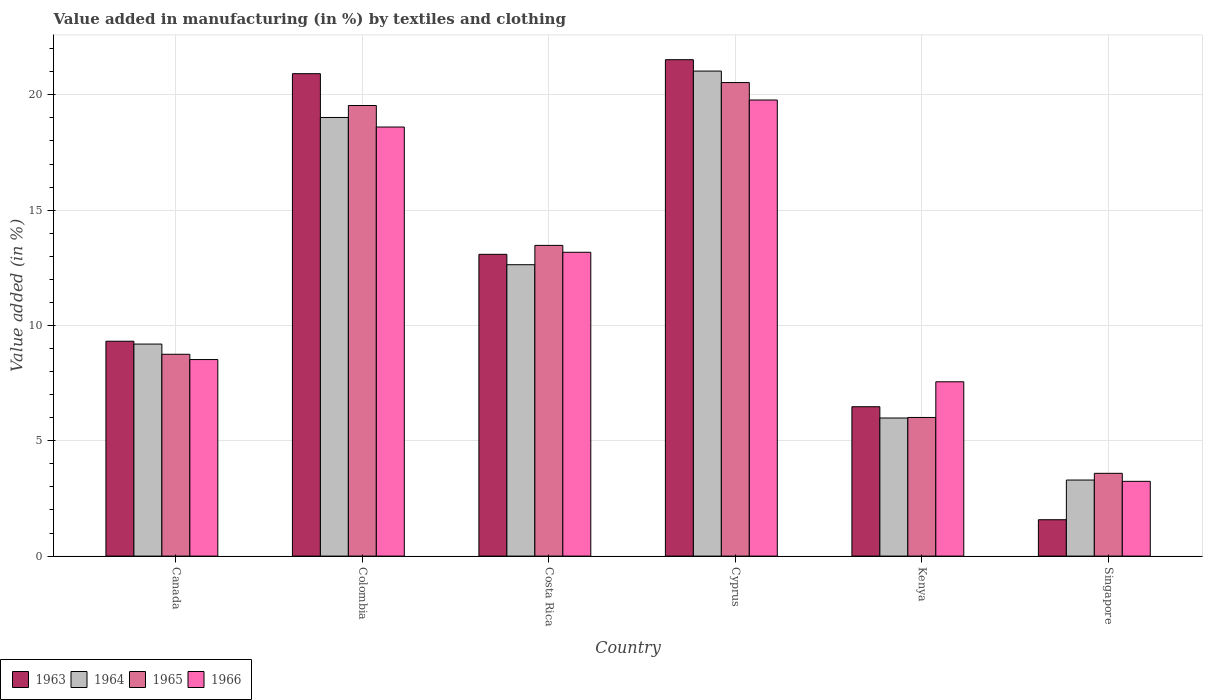Are the number of bars on each tick of the X-axis equal?
Provide a short and direct response. Yes. What is the label of the 4th group of bars from the left?
Your response must be concise. Cyprus. What is the percentage of value added in manufacturing by textiles and clothing in 1966 in Cyprus?
Offer a terse response. 19.78. Across all countries, what is the maximum percentage of value added in manufacturing by textiles and clothing in 1966?
Ensure brevity in your answer.  19.78. Across all countries, what is the minimum percentage of value added in manufacturing by textiles and clothing in 1964?
Offer a very short reply. 3.3. In which country was the percentage of value added in manufacturing by textiles and clothing in 1964 maximum?
Keep it short and to the point. Cyprus. In which country was the percentage of value added in manufacturing by textiles and clothing in 1966 minimum?
Offer a terse response. Singapore. What is the total percentage of value added in manufacturing by textiles and clothing in 1964 in the graph?
Ensure brevity in your answer.  71.16. What is the difference between the percentage of value added in manufacturing by textiles and clothing in 1966 in Colombia and that in Singapore?
Provide a short and direct response. 15.36. What is the difference between the percentage of value added in manufacturing by textiles and clothing in 1963 in Costa Rica and the percentage of value added in manufacturing by textiles and clothing in 1964 in Colombia?
Your answer should be very brief. -5.93. What is the average percentage of value added in manufacturing by textiles and clothing in 1966 per country?
Keep it short and to the point. 11.81. What is the difference between the percentage of value added in manufacturing by textiles and clothing of/in 1965 and percentage of value added in manufacturing by textiles and clothing of/in 1963 in Canada?
Your answer should be very brief. -0.57. What is the ratio of the percentage of value added in manufacturing by textiles and clothing in 1963 in Cyprus to that in Kenya?
Offer a terse response. 3.32. What is the difference between the highest and the second highest percentage of value added in manufacturing by textiles and clothing in 1965?
Ensure brevity in your answer.  -0.99. What is the difference between the highest and the lowest percentage of value added in manufacturing by textiles and clothing in 1965?
Your answer should be compact. 16.94. Is it the case that in every country, the sum of the percentage of value added in manufacturing by textiles and clothing in 1965 and percentage of value added in manufacturing by textiles and clothing in 1963 is greater than the sum of percentage of value added in manufacturing by textiles and clothing in 1964 and percentage of value added in manufacturing by textiles and clothing in 1966?
Offer a very short reply. No. What does the 4th bar from the left in Cyprus represents?
Your answer should be very brief. 1966. Is it the case that in every country, the sum of the percentage of value added in manufacturing by textiles and clothing in 1963 and percentage of value added in manufacturing by textiles and clothing in 1965 is greater than the percentage of value added in manufacturing by textiles and clothing in 1966?
Your response must be concise. Yes. How many bars are there?
Offer a terse response. 24. Are all the bars in the graph horizontal?
Make the answer very short. No. How many countries are there in the graph?
Make the answer very short. 6. What is the difference between two consecutive major ticks on the Y-axis?
Offer a terse response. 5. Does the graph contain any zero values?
Keep it short and to the point. No. How many legend labels are there?
Your answer should be compact. 4. What is the title of the graph?
Provide a succinct answer. Value added in manufacturing (in %) by textiles and clothing. What is the label or title of the X-axis?
Your response must be concise. Country. What is the label or title of the Y-axis?
Your response must be concise. Value added (in %). What is the Value added (in %) of 1963 in Canada?
Your answer should be very brief. 9.32. What is the Value added (in %) in 1964 in Canada?
Offer a very short reply. 9.19. What is the Value added (in %) of 1965 in Canada?
Your answer should be very brief. 8.75. What is the Value added (in %) in 1966 in Canada?
Your response must be concise. 8.52. What is the Value added (in %) of 1963 in Colombia?
Keep it short and to the point. 20.92. What is the Value added (in %) of 1964 in Colombia?
Provide a short and direct response. 19.02. What is the Value added (in %) of 1965 in Colombia?
Your answer should be compact. 19.54. What is the Value added (in %) of 1966 in Colombia?
Give a very brief answer. 18.6. What is the Value added (in %) of 1963 in Costa Rica?
Provide a succinct answer. 13.08. What is the Value added (in %) of 1964 in Costa Rica?
Offer a very short reply. 12.63. What is the Value added (in %) of 1965 in Costa Rica?
Keep it short and to the point. 13.47. What is the Value added (in %) in 1966 in Costa Rica?
Offer a very short reply. 13.17. What is the Value added (in %) of 1963 in Cyprus?
Keep it short and to the point. 21.52. What is the Value added (in %) of 1964 in Cyprus?
Ensure brevity in your answer.  21.03. What is the Value added (in %) in 1965 in Cyprus?
Offer a very short reply. 20.53. What is the Value added (in %) of 1966 in Cyprus?
Keep it short and to the point. 19.78. What is the Value added (in %) of 1963 in Kenya?
Provide a short and direct response. 6.48. What is the Value added (in %) in 1964 in Kenya?
Give a very brief answer. 5.99. What is the Value added (in %) of 1965 in Kenya?
Your answer should be compact. 6.01. What is the Value added (in %) in 1966 in Kenya?
Your answer should be compact. 7.56. What is the Value added (in %) of 1963 in Singapore?
Offer a very short reply. 1.58. What is the Value added (in %) of 1964 in Singapore?
Your response must be concise. 3.3. What is the Value added (in %) of 1965 in Singapore?
Your answer should be very brief. 3.59. What is the Value added (in %) of 1966 in Singapore?
Your answer should be compact. 3.24. Across all countries, what is the maximum Value added (in %) in 1963?
Provide a short and direct response. 21.52. Across all countries, what is the maximum Value added (in %) in 1964?
Your answer should be very brief. 21.03. Across all countries, what is the maximum Value added (in %) of 1965?
Your response must be concise. 20.53. Across all countries, what is the maximum Value added (in %) in 1966?
Provide a succinct answer. 19.78. Across all countries, what is the minimum Value added (in %) in 1963?
Your answer should be very brief. 1.58. Across all countries, what is the minimum Value added (in %) in 1964?
Ensure brevity in your answer.  3.3. Across all countries, what is the minimum Value added (in %) of 1965?
Offer a terse response. 3.59. Across all countries, what is the minimum Value added (in %) in 1966?
Keep it short and to the point. 3.24. What is the total Value added (in %) in 1963 in the graph?
Provide a succinct answer. 72.9. What is the total Value added (in %) in 1964 in the graph?
Ensure brevity in your answer.  71.16. What is the total Value added (in %) in 1965 in the graph?
Keep it short and to the point. 71.89. What is the total Value added (in %) of 1966 in the graph?
Your answer should be compact. 70.87. What is the difference between the Value added (in %) of 1963 in Canada and that in Colombia?
Ensure brevity in your answer.  -11.6. What is the difference between the Value added (in %) in 1964 in Canada and that in Colombia?
Your answer should be compact. -9.82. What is the difference between the Value added (in %) of 1965 in Canada and that in Colombia?
Provide a short and direct response. -10.79. What is the difference between the Value added (in %) in 1966 in Canada and that in Colombia?
Provide a short and direct response. -10.08. What is the difference between the Value added (in %) in 1963 in Canada and that in Costa Rica?
Provide a short and direct response. -3.77. What is the difference between the Value added (in %) of 1964 in Canada and that in Costa Rica?
Your response must be concise. -3.44. What is the difference between the Value added (in %) of 1965 in Canada and that in Costa Rica?
Your response must be concise. -4.72. What is the difference between the Value added (in %) of 1966 in Canada and that in Costa Rica?
Give a very brief answer. -4.65. What is the difference between the Value added (in %) of 1963 in Canada and that in Cyprus?
Your answer should be compact. -12.21. What is the difference between the Value added (in %) of 1964 in Canada and that in Cyprus?
Offer a very short reply. -11.84. What is the difference between the Value added (in %) in 1965 in Canada and that in Cyprus?
Your answer should be compact. -11.78. What is the difference between the Value added (in %) of 1966 in Canada and that in Cyprus?
Provide a short and direct response. -11.25. What is the difference between the Value added (in %) in 1963 in Canada and that in Kenya?
Provide a short and direct response. 2.84. What is the difference between the Value added (in %) of 1964 in Canada and that in Kenya?
Offer a very short reply. 3.21. What is the difference between the Value added (in %) of 1965 in Canada and that in Kenya?
Offer a terse response. 2.74. What is the difference between the Value added (in %) of 1966 in Canada and that in Kenya?
Provide a short and direct response. 0.96. What is the difference between the Value added (in %) in 1963 in Canada and that in Singapore?
Your answer should be very brief. 7.74. What is the difference between the Value added (in %) of 1964 in Canada and that in Singapore?
Ensure brevity in your answer.  5.9. What is the difference between the Value added (in %) in 1965 in Canada and that in Singapore?
Make the answer very short. 5.16. What is the difference between the Value added (in %) of 1966 in Canada and that in Singapore?
Keep it short and to the point. 5.28. What is the difference between the Value added (in %) of 1963 in Colombia and that in Costa Rica?
Keep it short and to the point. 7.83. What is the difference between the Value added (in %) in 1964 in Colombia and that in Costa Rica?
Your response must be concise. 6.38. What is the difference between the Value added (in %) in 1965 in Colombia and that in Costa Rica?
Make the answer very short. 6.06. What is the difference between the Value added (in %) of 1966 in Colombia and that in Costa Rica?
Your response must be concise. 5.43. What is the difference between the Value added (in %) in 1963 in Colombia and that in Cyprus?
Give a very brief answer. -0.61. What is the difference between the Value added (in %) in 1964 in Colombia and that in Cyprus?
Offer a very short reply. -2.01. What is the difference between the Value added (in %) in 1965 in Colombia and that in Cyprus?
Offer a terse response. -0.99. What is the difference between the Value added (in %) in 1966 in Colombia and that in Cyprus?
Make the answer very short. -1.17. What is the difference between the Value added (in %) in 1963 in Colombia and that in Kenya?
Offer a very short reply. 14.44. What is the difference between the Value added (in %) in 1964 in Colombia and that in Kenya?
Keep it short and to the point. 13.03. What is the difference between the Value added (in %) in 1965 in Colombia and that in Kenya?
Keep it short and to the point. 13.53. What is the difference between the Value added (in %) in 1966 in Colombia and that in Kenya?
Ensure brevity in your answer.  11.05. What is the difference between the Value added (in %) of 1963 in Colombia and that in Singapore?
Offer a very short reply. 19.34. What is the difference between the Value added (in %) of 1964 in Colombia and that in Singapore?
Your answer should be very brief. 15.72. What is the difference between the Value added (in %) in 1965 in Colombia and that in Singapore?
Your answer should be compact. 15.95. What is the difference between the Value added (in %) of 1966 in Colombia and that in Singapore?
Your answer should be very brief. 15.36. What is the difference between the Value added (in %) of 1963 in Costa Rica and that in Cyprus?
Keep it short and to the point. -8.44. What is the difference between the Value added (in %) of 1964 in Costa Rica and that in Cyprus?
Ensure brevity in your answer.  -8.4. What is the difference between the Value added (in %) of 1965 in Costa Rica and that in Cyprus?
Ensure brevity in your answer.  -7.06. What is the difference between the Value added (in %) of 1966 in Costa Rica and that in Cyprus?
Your response must be concise. -6.6. What is the difference between the Value added (in %) in 1963 in Costa Rica and that in Kenya?
Keep it short and to the point. 6.61. What is the difference between the Value added (in %) of 1964 in Costa Rica and that in Kenya?
Ensure brevity in your answer.  6.65. What is the difference between the Value added (in %) in 1965 in Costa Rica and that in Kenya?
Offer a terse response. 7.46. What is the difference between the Value added (in %) in 1966 in Costa Rica and that in Kenya?
Provide a succinct answer. 5.62. What is the difference between the Value added (in %) of 1963 in Costa Rica and that in Singapore?
Ensure brevity in your answer.  11.51. What is the difference between the Value added (in %) in 1964 in Costa Rica and that in Singapore?
Provide a short and direct response. 9.34. What is the difference between the Value added (in %) of 1965 in Costa Rica and that in Singapore?
Provide a succinct answer. 9.88. What is the difference between the Value added (in %) of 1966 in Costa Rica and that in Singapore?
Ensure brevity in your answer.  9.93. What is the difference between the Value added (in %) in 1963 in Cyprus and that in Kenya?
Give a very brief answer. 15.05. What is the difference between the Value added (in %) in 1964 in Cyprus and that in Kenya?
Your answer should be very brief. 15.04. What is the difference between the Value added (in %) of 1965 in Cyprus and that in Kenya?
Provide a short and direct response. 14.52. What is the difference between the Value added (in %) in 1966 in Cyprus and that in Kenya?
Offer a very short reply. 12.22. What is the difference between the Value added (in %) in 1963 in Cyprus and that in Singapore?
Offer a very short reply. 19.95. What is the difference between the Value added (in %) of 1964 in Cyprus and that in Singapore?
Keep it short and to the point. 17.73. What is the difference between the Value added (in %) of 1965 in Cyprus and that in Singapore?
Offer a terse response. 16.94. What is the difference between the Value added (in %) in 1966 in Cyprus and that in Singapore?
Provide a short and direct response. 16.53. What is the difference between the Value added (in %) of 1963 in Kenya and that in Singapore?
Give a very brief answer. 4.9. What is the difference between the Value added (in %) of 1964 in Kenya and that in Singapore?
Give a very brief answer. 2.69. What is the difference between the Value added (in %) of 1965 in Kenya and that in Singapore?
Provide a short and direct response. 2.42. What is the difference between the Value added (in %) in 1966 in Kenya and that in Singapore?
Provide a succinct answer. 4.32. What is the difference between the Value added (in %) of 1963 in Canada and the Value added (in %) of 1964 in Colombia?
Give a very brief answer. -9.7. What is the difference between the Value added (in %) of 1963 in Canada and the Value added (in %) of 1965 in Colombia?
Provide a succinct answer. -10.22. What is the difference between the Value added (in %) in 1963 in Canada and the Value added (in %) in 1966 in Colombia?
Ensure brevity in your answer.  -9.29. What is the difference between the Value added (in %) in 1964 in Canada and the Value added (in %) in 1965 in Colombia?
Ensure brevity in your answer.  -10.34. What is the difference between the Value added (in %) in 1964 in Canada and the Value added (in %) in 1966 in Colombia?
Make the answer very short. -9.41. What is the difference between the Value added (in %) in 1965 in Canada and the Value added (in %) in 1966 in Colombia?
Your response must be concise. -9.85. What is the difference between the Value added (in %) of 1963 in Canada and the Value added (in %) of 1964 in Costa Rica?
Offer a terse response. -3.32. What is the difference between the Value added (in %) in 1963 in Canada and the Value added (in %) in 1965 in Costa Rica?
Offer a terse response. -4.16. What is the difference between the Value added (in %) in 1963 in Canada and the Value added (in %) in 1966 in Costa Rica?
Your response must be concise. -3.86. What is the difference between the Value added (in %) in 1964 in Canada and the Value added (in %) in 1965 in Costa Rica?
Your answer should be compact. -4.28. What is the difference between the Value added (in %) in 1964 in Canada and the Value added (in %) in 1966 in Costa Rica?
Your answer should be compact. -3.98. What is the difference between the Value added (in %) of 1965 in Canada and the Value added (in %) of 1966 in Costa Rica?
Keep it short and to the point. -4.42. What is the difference between the Value added (in %) of 1963 in Canada and the Value added (in %) of 1964 in Cyprus?
Provide a succinct answer. -11.71. What is the difference between the Value added (in %) of 1963 in Canada and the Value added (in %) of 1965 in Cyprus?
Offer a very short reply. -11.21. What is the difference between the Value added (in %) in 1963 in Canada and the Value added (in %) in 1966 in Cyprus?
Give a very brief answer. -10.46. What is the difference between the Value added (in %) of 1964 in Canada and the Value added (in %) of 1965 in Cyprus?
Make the answer very short. -11.34. What is the difference between the Value added (in %) in 1964 in Canada and the Value added (in %) in 1966 in Cyprus?
Give a very brief answer. -10.58. What is the difference between the Value added (in %) in 1965 in Canada and the Value added (in %) in 1966 in Cyprus?
Offer a terse response. -11.02. What is the difference between the Value added (in %) in 1963 in Canada and the Value added (in %) in 1964 in Kenya?
Ensure brevity in your answer.  3.33. What is the difference between the Value added (in %) in 1963 in Canada and the Value added (in %) in 1965 in Kenya?
Give a very brief answer. 3.31. What is the difference between the Value added (in %) in 1963 in Canada and the Value added (in %) in 1966 in Kenya?
Provide a succinct answer. 1.76. What is the difference between the Value added (in %) of 1964 in Canada and the Value added (in %) of 1965 in Kenya?
Provide a short and direct response. 3.18. What is the difference between the Value added (in %) of 1964 in Canada and the Value added (in %) of 1966 in Kenya?
Provide a succinct answer. 1.64. What is the difference between the Value added (in %) of 1965 in Canada and the Value added (in %) of 1966 in Kenya?
Make the answer very short. 1.19. What is the difference between the Value added (in %) of 1963 in Canada and the Value added (in %) of 1964 in Singapore?
Provide a succinct answer. 6.02. What is the difference between the Value added (in %) in 1963 in Canada and the Value added (in %) in 1965 in Singapore?
Your response must be concise. 5.73. What is the difference between the Value added (in %) of 1963 in Canada and the Value added (in %) of 1966 in Singapore?
Provide a short and direct response. 6.08. What is the difference between the Value added (in %) in 1964 in Canada and the Value added (in %) in 1965 in Singapore?
Offer a very short reply. 5.6. What is the difference between the Value added (in %) of 1964 in Canada and the Value added (in %) of 1966 in Singapore?
Make the answer very short. 5.95. What is the difference between the Value added (in %) of 1965 in Canada and the Value added (in %) of 1966 in Singapore?
Offer a very short reply. 5.51. What is the difference between the Value added (in %) in 1963 in Colombia and the Value added (in %) in 1964 in Costa Rica?
Provide a short and direct response. 8.28. What is the difference between the Value added (in %) in 1963 in Colombia and the Value added (in %) in 1965 in Costa Rica?
Give a very brief answer. 7.44. What is the difference between the Value added (in %) in 1963 in Colombia and the Value added (in %) in 1966 in Costa Rica?
Keep it short and to the point. 7.74. What is the difference between the Value added (in %) of 1964 in Colombia and the Value added (in %) of 1965 in Costa Rica?
Your answer should be very brief. 5.55. What is the difference between the Value added (in %) in 1964 in Colombia and the Value added (in %) in 1966 in Costa Rica?
Give a very brief answer. 5.84. What is the difference between the Value added (in %) of 1965 in Colombia and the Value added (in %) of 1966 in Costa Rica?
Your response must be concise. 6.36. What is the difference between the Value added (in %) of 1963 in Colombia and the Value added (in %) of 1964 in Cyprus?
Your answer should be very brief. -0.11. What is the difference between the Value added (in %) in 1963 in Colombia and the Value added (in %) in 1965 in Cyprus?
Provide a succinct answer. 0.39. What is the difference between the Value added (in %) of 1963 in Colombia and the Value added (in %) of 1966 in Cyprus?
Give a very brief answer. 1.14. What is the difference between the Value added (in %) of 1964 in Colombia and the Value added (in %) of 1965 in Cyprus?
Make the answer very short. -1.51. What is the difference between the Value added (in %) in 1964 in Colombia and the Value added (in %) in 1966 in Cyprus?
Offer a very short reply. -0.76. What is the difference between the Value added (in %) of 1965 in Colombia and the Value added (in %) of 1966 in Cyprus?
Your answer should be compact. -0.24. What is the difference between the Value added (in %) of 1963 in Colombia and the Value added (in %) of 1964 in Kenya?
Offer a terse response. 14.93. What is the difference between the Value added (in %) of 1963 in Colombia and the Value added (in %) of 1965 in Kenya?
Offer a terse response. 14.91. What is the difference between the Value added (in %) in 1963 in Colombia and the Value added (in %) in 1966 in Kenya?
Make the answer very short. 13.36. What is the difference between the Value added (in %) of 1964 in Colombia and the Value added (in %) of 1965 in Kenya?
Keep it short and to the point. 13.01. What is the difference between the Value added (in %) of 1964 in Colombia and the Value added (in %) of 1966 in Kenya?
Provide a short and direct response. 11.46. What is the difference between the Value added (in %) in 1965 in Colombia and the Value added (in %) in 1966 in Kenya?
Offer a very short reply. 11.98. What is the difference between the Value added (in %) of 1963 in Colombia and the Value added (in %) of 1964 in Singapore?
Your answer should be very brief. 17.62. What is the difference between the Value added (in %) in 1963 in Colombia and the Value added (in %) in 1965 in Singapore?
Offer a very short reply. 17.33. What is the difference between the Value added (in %) of 1963 in Colombia and the Value added (in %) of 1966 in Singapore?
Provide a short and direct response. 17.68. What is the difference between the Value added (in %) of 1964 in Colombia and the Value added (in %) of 1965 in Singapore?
Ensure brevity in your answer.  15.43. What is the difference between the Value added (in %) of 1964 in Colombia and the Value added (in %) of 1966 in Singapore?
Offer a very short reply. 15.78. What is the difference between the Value added (in %) in 1965 in Colombia and the Value added (in %) in 1966 in Singapore?
Keep it short and to the point. 16.3. What is the difference between the Value added (in %) of 1963 in Costa Rica and the Value added (in %) of 1964 in Cyprus?
Provide a succinct answer. -7.95. What is the difference between the Value added (in %) of 1963 in Costa Rica and the Value added (in %) of 1965 in Cyprus?
Your response must be concise. -7.45. What is the difference between the Value added (in %) of 1963 in Costa Rica and the Value added (in %) of 1966 in Cyprus?
Keep it short and to the point. -6.69. What is the difference between the Value added (in %) in 1964 in Costa Rica and the Value added (in %) in 1965 in Cyprus?
Your response must be concise. -7.9. What is the difference between the Value added (in %) of 1964 in Costa Rica and the Value added (in %) of 1966 in Cyprus?
Give a very brief answer. -7.14. What is the difference between the Value added (in %) in 1965 in Costa Rica and the Value added (in %) in 1966 in Cyprus?
Your answer should be very brief. -6.3. What is the difference between the Value added (in %) in 1963 in Costa Rica and the Value added (in %) in 1964 in Kenya?
Give a very brief answer. 7.1. What is the difference between the Value added (in %) of 1963 in Costa Rica and the Value added (in %) of 1965 in Kenya?
Keep it short and to the point. 7.07. What is the difference between the Value added (in %) in 1963 in Costa Rica and the Value added (in %) in 1966 in Kenya?
Offer a terse response. 5.53. What is the difference between the Value added (in %) of 1964 in Costa Rica and the Value added (in %) of 1965 in Kenya?
Provide a succinct answer. 6.62. What is the difference between the Value added (in %) in 1964 in Costa Rica and the Value added (in %) in 1966 in Kenya?
Offer a terse response. 5.08. What is the difference between the Value added (in %) of 1965 in Costa Rica and the Value added (in %) of 1966 in Kenya?
Make the answer very short. 5.91. What is the difference between the Value added (in %) in 1963 in Costa Rica and the Value added (in %) in 1964 in Singapore?
Keep it short and to the point. 9.79. What is the difference between the Value added (in %) of 1963 in Costa Rica and the Value added (in %) of 1965 in Singapore?
Provide a short and direct response. 9.5. What is the difference between the Value added (in %) of 1963 in Costa Rica and the Value added (in %) of 1966 in Singapore?
Offer a terse response. 9.84. What is the difference between the Value added (in %) of 1964 in Costa Rica and the Value added (in %) of 1965 in Singapore?
Offer a terse response. 9.04. What is the difference between the Value added (in %) of 1964 in Costa Rica and the Value added (in %) of 1966 in Singapore?
Your answer should be very brief. 9.39. What is the difference between the Value added (in %) in 1965 in Costa Rica and the Value added (in %) in 1966 in Singapore?
Your answer should be very brief. 10.23. What is the difference between the Value added (in %) of 1963 in Cyprus and the Value added (in %) of 1964 in Kenya?
Offer a terse response. 15.54. What is the difference between the Value added (in %) in 1963 in Cyprus and the Value added (in %) in 1965 in Kenya?
Offer a terse response. 15.51. What is the difference between the Value added (in %) in 1963 in Cyprus and the Value added (in %) in 1966 in Kenya?
Ensure brevity in your answer.  13.97. What is the difference between the Value added (in %) of 1964 in Cyprus and the Value added (in %) of 1965 in Kenya?
Give a very brief answer. 15.02. What is the difference between the Value added (in %) in 1964 in Cyprus and the Value added (in %) in 1966 in Kenya?
Give a very brief answer. 13.47. What is the difference between the Value added (in %) in 1965 in Cyprus and the Value added (in %) in 1966 in Kenya?
Keep it short and to the point. 12.97. What is the difference between the Value added (in %) in 1963 in Cyprus and the Value added (in %) in 1964 in Singapore?
Provide a succinct answer. 18.23. What is the difference between the Value added (in %) in 1963 in Cyprus and the Value added (in %) in 1965 in Singapore?
Your answer should be compact. 17.93. What is the difference between the Value added (in %) in 1963 in Cyprus and the Value added (in %) in 1966 in Singapore?
Your answer should be very brief. 18.28. What is the difference between the Value added (in %) of 1964 in Cyprus and the Value added (in %) of 1965 in Singapore?
Make the answer very short. 17.44. What is the difference between the Value added (in %) of 1964 in Cyprus and the Value added (in %) of 1966 in Singapore?
Make the answer very short. 17.79. What is the difference between the Value added (in %) of 1965 in Cyprus and the Value added (in %) of 1966 in Singapore?
Keep it short and to the point. 17.29. What is the difference between the Value added (in %) of 1963 in Kenya and the Value added (in %) of 1964 in Singapore?
Your answer should be very brief. 3.18. What is the difference between the Value added (in %) in 1963 in Kenya and the Value added (in %) in 1965 in Singapore?
Your response must be concise. 2.89. What is the difference between the Value added (in %) in 1963 in Kenya and the Value added (in %) in 1966 in Singapore?
Provide a succinct answer. 3.24. What is the difference between the Value added (in %) of 1964 in Kenya and the Value added (in %) of 1965 in Singapore?
Offer a very short reply. 2.4. What is the difference between the Value added (in %) in 1964 in Kenya and the Value added (in %) in 1966 in Singapore?
Make the answer very short. 2.75. What is the difference between the Value added (in %) of 1965 in Kenya and the Value added (in %) of 1966 in Singapore?
Your answer should be very brief. 2.77. What is the average Value added (in %) in 1963 per country?
Your answer should be very brief. 12.15. What is the average Value added (in %) in 1964 per country?
Give a very brief answer. 11.86. What is the average Value added (in %) of 1965 per country?
Your answer should be compact. 11.98. What is the average Value added (in %) in 1966 per country?
Give a very brief answer. 11.81. What is the difference between the Value added (in %) of 1963 and Value added (in %) of 1964 in Canada?
Ensure brevity in your answer.  0.12. What is the difference between the Value added (in %) in 1963 and Value added (in %) in 1965 in Canada?
Your answer should be compact. 0.57. What is the difference between the Value added (in %) of 1963 and Value added (in %) of 1966 in Canada?
Your answer should be very brief. 0.8. What is the difference between the Value added (in %) of 1964 and Value added (in %) of 1965 in Canada?
Offer a very short reply. 0.44. What is the difference between the Value added (in %) of 1964 and Value added (in %) of 1966 in Canada?
Offer a very short reply. 0.67. What is the difference between the Value added (in %) in 1965 and Value added (in %) in 1966 in Canada?
Offer a terse response. 0.23. What is the difference between the Value added (in %) in 1963 and Value added (in %) in 1964 in Colombia?
Offer a terse response. 1.9. What is the difference between the Value added (in %) of 1963 and Value added (in %) of 1965 in Colombia?
Your answer should be compact. 1.38. What is the difference between the Value added (in %) of 1963 and Value added (in %) of 1966 in Colombia?
Offer a very short reply. 2.31. What is the difference between the Value added (in %) of 1964 and Value added (in %) of 1965 in Colombia?
Your answer should be compact. -0.52. What is the difference between the Value added (in %) of 1964 and Value added (in %) of 1966 in Colombia?
Provide a succinct answer. 0.41. What is the difference between the Value added (in %) in 1965 and Value added (in %) in 1966 in Colombia?
Your answer should be very brief. 0.93. What is the difference between the Value added (in %) of 1963 and Value added (in %) of 1964 in Costa Rica?
Keep it short and to the point. 0.45. What is the difference between the Value added (in %) of 1963 and Value added (in %) of 1965 in Costa Rica?
Give a very brief answer. -0.39. What is the difference between the Value added (in %) of 1963 and Value added (in %) of 1966 in Costa Rica?
Offer a terse response. -0.09. What is the difference between the Value added (in %) in 1964 and Value added (in %) in 1965 in Costa Rica?
Offer a terse response. -0.84. What is the difference between the Value added (in %) in 1964 and Value added (in %) in 1966 in Costa Rica?
Ensure brevity in your answer.  -0.54. What is the difference between the Value added (in %) of 1965 and Value added (in %) of 1966 in Costa Rica?
Offer a very short reply. 0.3. What is the difference between the Value added (in %) of 1963 and Value added (in %) of 1964 in Cyprus?
Ensure brevity in your answer.  0.49. What is the difference between the Value added (in %) in 1963 and Value added (in %) in 1966 in Cyprus?
Give a very brief answer. 1.75. What is the difference between the Value added (in %) of 1964 and Value added (in %) of 1965 in Cyprus?
Offer a terse response. 0.5. What is the difference between the Value added (in %) in 1964 and Value added (in %) in 1966 in Cyprus?
Ensure brevity in your answer.  1.25. What is the difference between the Value added (in %) of 1965 and Value added (in %) of 1966 in Cyprus?
Ensure brevity in your answer.  0.76. What is the difference between the Value added (in %) of 1963 and Value added (in %) of 1964 in Kenya?
Your response must be concise. 0.49. What is the difference between the Value added (in %) in 1963 and Value added (in %) in 1965 in Kenya?
Your answer should be very brief. 0.47. What is the difference between the Value added (in %) in 1963 and Value added (in %) in 1966 in Kenya?
Offer a very short reply. -1.08. What is the difference between the Value added (in %) in 1964 and Value added (in %) in 1965 in Kenya?
Give a very brief answer. -0.02. What is the difference between the Value added (in %) in 1964 and Value added (in %) in 1966 in Kenya?
Your answer should be very brief. -1.57. What is the difference between the Value added (in %) in 1965 and Value added (in %) in 1966 in Kenya?
Provide a short and direct response. -1.55. What is the difference between the Value added (in %) of 1963 and Value added (in %) of 1964 in Singapore?
Offer a very short reply. -1.72. What is the difference between the Value added (in %) in 1963 and Value added (in %) in 1965 in Singapore?
Your answer should be compact. -2.01. What is the difference between the Value added (in %) of 1963 and Value added (in %) of 1966 in Singapore?
Ensure brevity in your answer.  -1.66. What is the difference between the Value added (in %) in 1964 and Value added (in %) in 1965 in Singapore?
Offer a terse response. -0.29. What is the difference between the Value added (in %) in 1964 and Value added (in %) in 1966 in Singapore?
Ensure brevity in your answer.  0.06. What is the difference between the Value added (in %) in 1965 and Value added (in %) in 1966 in Singapore?
Offer a very short reply. 0.35. What is the ratio of the Value added (in %) in 1963 in Canada to that in Colombia?
Give a very brief answer. 0.45. What is the ratio of the Value added (in %) of 1964 in Canada to that in Colombia?
Your answer should be very brief. 0.48. What is the ratio of the Value added (in %) in 1965 in Canada to that in Colombia?
Offer a terse response. 0.45. What is the ratio of the Value added (in %) in 1966 in Canada to that in Colombia?
Provide a short and direct response. 0.46. What is the ratio of the Value added (in %) in 1963 in Canada to that in Costa Rica?
Offer a terse response. 0.71. What is the ratio of the Value added (in %) of 1964 in Canada to that in Costa Rica?
Give a very brief answer. 0.73. What is the ratio of the Value added (in %) of 1965 in Canada to that in Costa Rica?
Offer a terse response. 0.65. What is the ratio of the Value added (in %) of 1966 in Canada to that in Costa Rica?
Make the answer very short. 0.65. What is the ratio of the Value added (in %) of 1963 in Canada to that in Cyprus?
Provide a succinct answer. 0.43. What is the ratio of the Value added (in %) of 1964 in Canada to that in Cyprus?
Ensure brevity in your answer.  0.44. What is the ratio of the Value added (in %) in 1965 in Canada to that in Cyprus?
Your answer should be compact. 0.43. What is the ratio of the Value added (in %) of 1966 in Canada to that in Cyprus?
Keep it short and to the point. 0.43. What is the ratio of the Value added (in %) of 1963 in Canada to that in Kenya?
Ensure brevity in your answer.  1.44. What is the ratio of the Value added (in %) of 1964 in Canada to that in Kenya?
Offer a terse response. 1.54. What is the ratio of the Value added (in %) in 1965 in Canada to that in Kenya?
Keep it short and to the point. 1.46. What is the ratio of the Value added (in %) of 1966 in Canada to that in Kenya?
Provide a succinct answer. 1.13. What is the ratio of the Value added (in %) in 1963 in Canada to that in Singapore?
Provide a succinct answer. 5.91. What is the ratio of the Value added (in %) in 1964 in Canada to that in Singapore?
Ensure brevity in your answer.  2.79. What is the ratio of the Value added (in %) of 1965 in Canada to that in Singapore?
Keep it short and to the point. 2.44. What is the ratio of the Value added (in %) in 1966 in Canada to that in Singapore?
Offer a terse response. 2.63. What is the ratio of the Value added (in %) of 1963 in Colombia to that in Costa Rica?
Ensure brevity in your answer.  1.6. What is the ratio of the Value added (in %) of 1964 in Colombia to that in Costa Rica?
Your response must be concise. 1.51. What is the ratio of the Value added (in %) of 1965 in Colombia to that in Costa Rica?
Give a very brief answer. 1.45. What is the ratio of the Value added (in %) in 1966 in Colombia to that in Costa Rica?
Offer a very short reply. 1.41. What is the ratio of the Value added (in %) of 1963 in Colombia to that in Cyprus?
Provide a succinct answer. 0.97. What is the ratio of the Value added (in %) in 1964 in Colombia to that in Cyprus?
Ensure brevity in your answer.  0.9. What is the ratio of the Value added (in %) in 1965 in Colombia to that in Cyprus?
Provide a succinct answer. 0.95. What is the ratio of the Value added (in %) of 1966 in Colombia to that in Cyprus?
Your answer should be compact. 0.94. What is the ratio of the Value added (in %) of 1963 in Colombia to that in Kenya?
Make the answer very short. 3.23. What is the ratio of the Value added (in %) in 1964 in Colombia to that in Kenya?
Give a very brief answer. 3.18. What is the ratio of the Value added (in %) of 1966 in Colombia to that in Kenya?
Provide a short and direct response. 2.46. What is the ratio of the Value added (in %) in 1963 in Colombia to that in Singapore?
Give a very brief answer. 13.26. What is the ratio of the Value added (in %) of 1964 in Colombia to that in Singapore?
Provide a short and direct response. 5.77. What is the ratio of the Value added (in %) in 1965 in Colombia to that in Singapore?
Provide a short and direct response. 5.44. What is the ratio of the Value added (in %) in 1966 in Colombia to that in Singapore?
Your answer should be compact. 5.74. What is the ratio of the Value added (in %) of 1963 in Costa Rica to that in Cyprus?
Ensure brevity in your answer.  0.61. What is the ratio of the Value added (in %) of 1964 in Costa Rica to that in Cyprus?
Offer a very short reply. 0.6. What is the ratio of the Value added (in %) of 1965 in Costa Rica to that in Cyprus?
Offer a terse response. 0.66. What is the ratio of the Value added (in %) in 1966 in Costa Rica to that in Cyprus?
Provide a short and direct response. 0.67. What is the ratio of the Value added (in %) in 1963 in Costa Rica to that in Kenya?
Offer a very short reply. 2.02. What is the ratio of the Value added (in %) of 1964 in Costa Rica to that in Kenya?
Make the answer very short. 2.11. What is the ratio of the Value added (in %) in 1965 in Costa Rica to that in Kenya?
Keep it short and to the point. 2.24. What is the ratio of the Value added (in %) in 1966 in Costa Rica to that in Kenya?
Provide a succinct answer. 1.74. What is the ratio of the Value added (in %) in 1963 in Costa Rica to that in Singapore?
Give a very brief answer. 8.3. What is the ratio of the Value added (in %) in 1964 in Costa Rica to that in Singapore?
Your response must be concise. 3.83. What is the ratio of the Value added (in %) of 1965 in Costa Rica to that in Singapore?
Offer a very short reply. 3.75. What is the ratio of the Value added (in %) in 1966 in Costa Rica to that in Singapore?
Offer a terse response. 4.06. What is the ratio of the Value added (in %) in 1963 in Cyprus to that in Kenya?
Provide a succinct answer. 3.32. What is the ratio of the Value added (in %) of 1964 in Cyprus to that in Kenya?
Make the answer very short. 3.51. What is the ratio of the Value added (in %) in 1965 in Cyprus to that in Kenya?
Your response must be concise. 3.42. What is the ratio of the Value added (in %) of 1966 in Cyprus to that in Kenya?
Your answer should be compact. 2.62. What is the ratio of the Value added (in %) in 1963 in Cyprus to that in Singapore?
Your response must be concise. 13.65. What is the ratio of the Value added (in %) in 1964 in Cyprus to that in Singapore?
Make the answer very short. 6.38. What is the ratio of the Value added (in %) in 1965 in Cyprus to that in Singapore?
Offer a very short reply. 5.72. What is the ratio of the Value added (in %) in 1966 in Cyprus to that in Singapore?
Make the answer very short. 6.1. What is the ratio of the Value added (in %) of 1963 in Kenya to that in Singapore?
Your answer should be very brief. 4.11. What is the ratio of the Value added (in %) in 1964 in Kenya to that in Singapore?
Keep it short and to the point. 1.82. What is the ratio of the Value added (in %) of 1965 in Kenya to that in Singapore?
Give a very brief answer. 1.67. What is the ratio of the Value added (in %) of 1966 in Kenya to that in Singapore?
Your answer should be compact. 2.33. What is the difference between the highest and the second highest Value added (in %) of 1963?
Offer a terse response. 0.61. What is the difference between the highest and the second highest Value added (in %) of 1964?
Give a very brief answer. 2.01. What is the difference between the highest and the second highest Value added (in %) in 1965?
Make the answer very short. 0.99. What is the difference between the highest and the second highest Value added (in %) of 1966?
Make the answer very short. 1.17. What is the difference between the highest and the lowest Value added (in %) in 1963?
Keep it short and to the point. 19.95. What is the difference between the highest and the lowest Value added (in %) of 1964?
Provide a short and direct response. 17.73. What is the difference between the highest and the lowest Value added (in %) in 1965?
Ensure brevity in your answer.  16.94. What is the difference between the highest and the lowest Value added (in %) of 1966?
Ensure brevity in your answer.  16.53. 